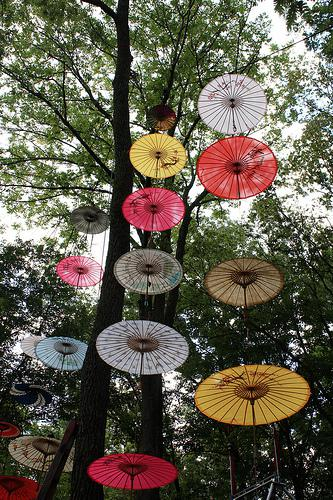Question: how many pink fans are there?
Choices:
A. 1.
B. 5.
C. 3.
D. 9.
Answer with the letter. Answer: C Question: where are the fans?
Choices:
A. Hung from the ceiling.
B. Hung from trees.
C. Hung on the roof.
D. Hung on the porch.
Answer with the letter. Answer: B 